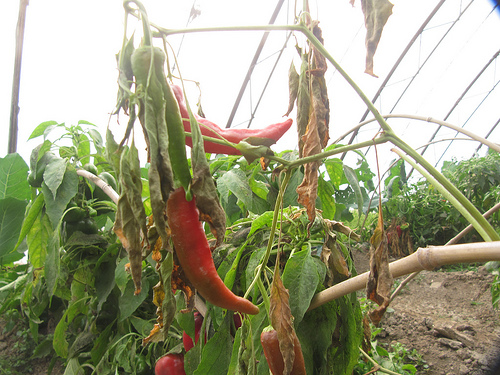<image>
Is there a pepper on the vine? Yes. Looking at the image, I can see the pepper is positioned on top of the vine, with the vine providing support. 